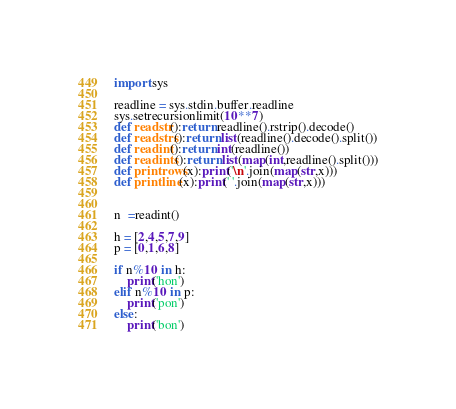Convert code to text. <code><loc_0><loc_0><loc_500><loc_500><_Python_>import sys

readline = sys.stdin.buffer.readline
sys.setrecursionlimit(10**7)
def readstr():return readline().rstrip().decode()
def readstrs():return list(readline().decode().split())
def readint():return int(readline())
def readints():return list(map(int,readline().split()))
def printrows(x):print('\n'.join(map(str,x)))
def printline(x):print(' '.join(map(str,x)))


n  =readint()

h = [2,4,5,7,9]
p = [0,1,6,8]

if n%10 in h:
    print('hon')
elif n%10 in p:
    print('pon')
else:
    print('bon')</code> 